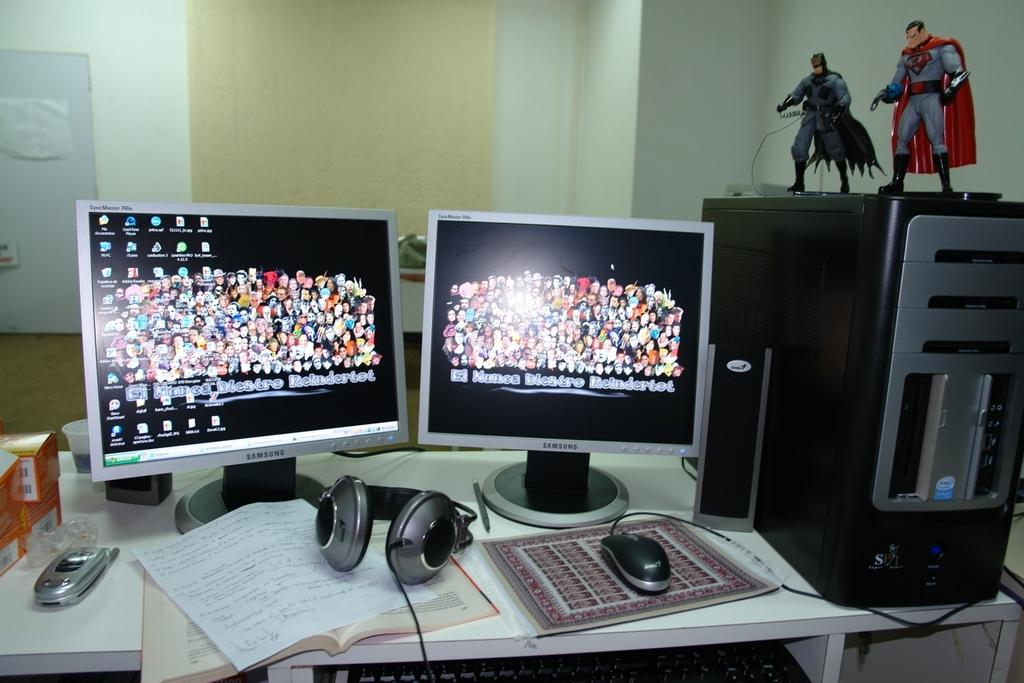How many monitors are visible in the image? There are two monitors in the image. What type of device is used for audio input and output in the image? There is a headset in the image. What device is used for controlling the cursor on the monitors? There is a mouse in the image. What can be seen in the background of the image? There is a wall, a door, action figures, and a CPU on a table in the background of the image. What type of letter is being written on the monitors in the image? There is no letter being written on the monitors in the image. Can you describe the coastline visible in the background of the image? There is no coastline visible in the background of the image. 